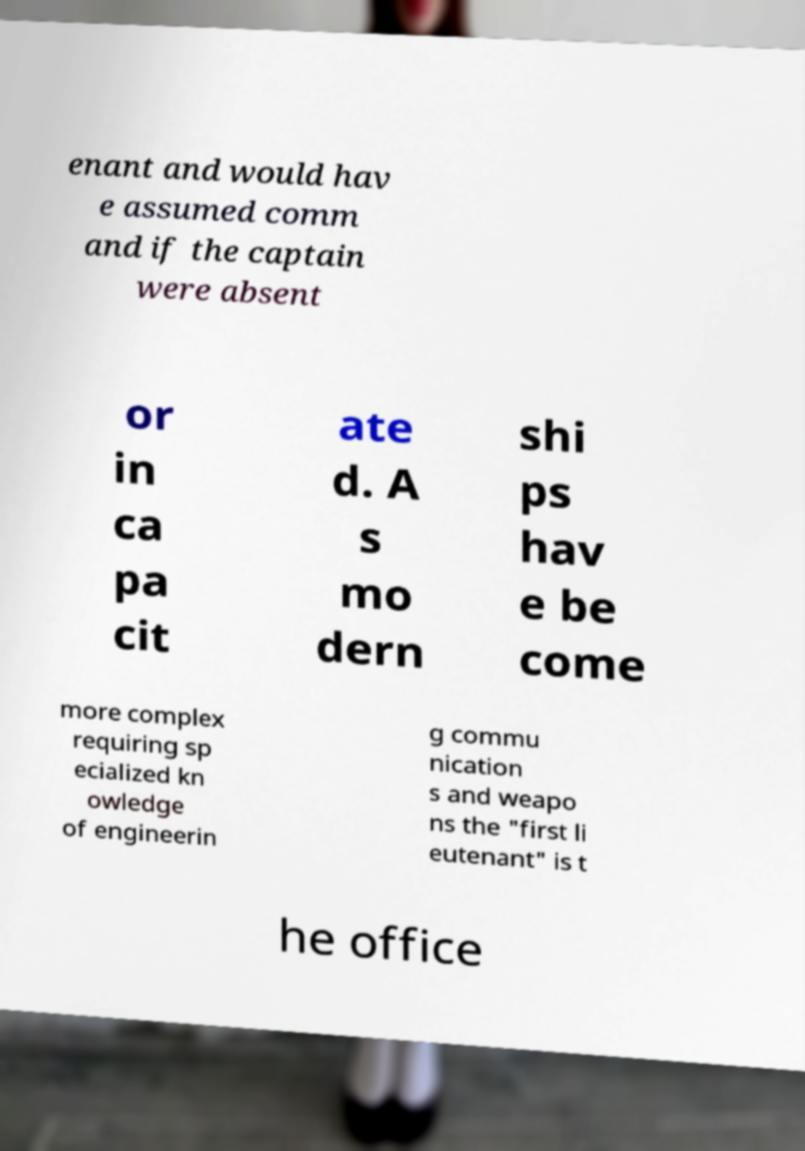I need the written content from this picture converted into text. Can you do that? enant and would hav e assumed comm and if the captain were absent or in ca pa cit ate d. A s mo dern shi ps hav e be come more complex requiring sp ecialized kn owledge of engineerin g commu nication s and weapo ns the "first li eutenant" is t he office 